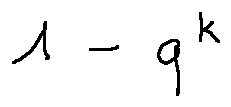<formula> <loc_0><loc_0><loc_500><loc_500>1 - q ^ { k }</formula> 